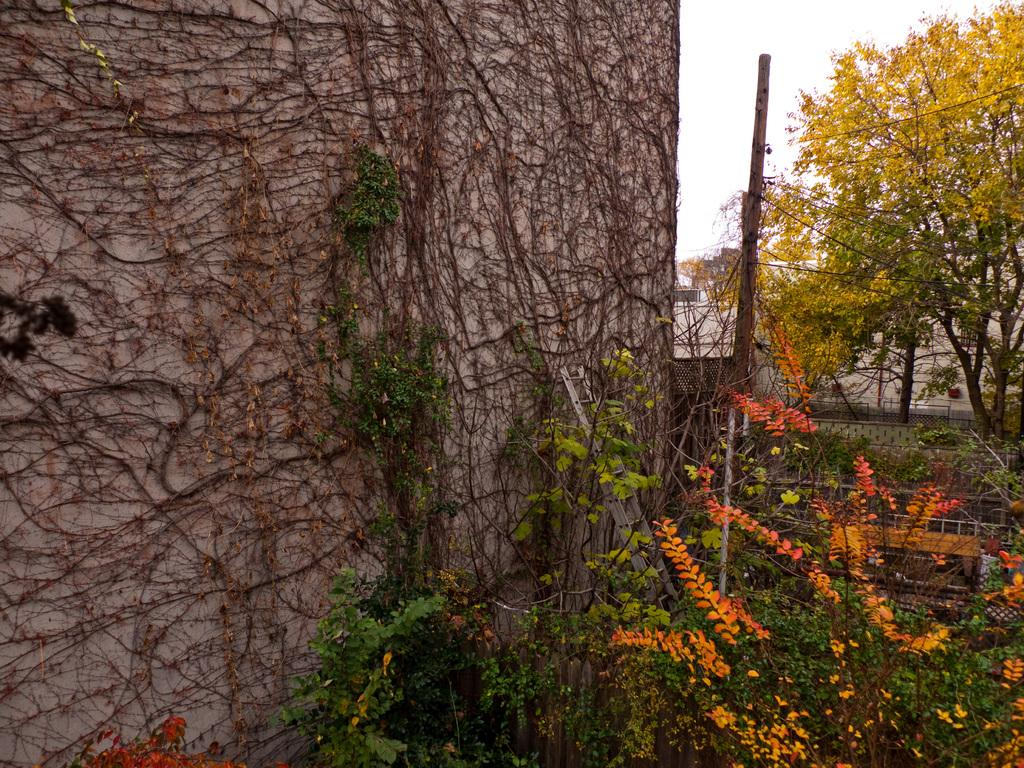What type of structure is in the image? There is a rock wall in the image. What is growing on the rock wall? There are plant saplings on the rock wall. What can be seen near a path in the image? There are plants near a path in the image. What is visible in the background of the image? There is a pole and trees visible in the background of the image. Can you tell me how many goats are grazing near the rock wall in the image? There are no goats present in the image; it only features a rock wall with plant saplings and plants near a path. What type of recess activity is happening near the rock wall in the image? There is no recess activity depicted in the image; it is a landscape scene with a rock wall, plant saplings, and plants near a path. 